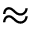<formula> <loc_0><loc_0><loc_500><loc_500>\approx</formula> 